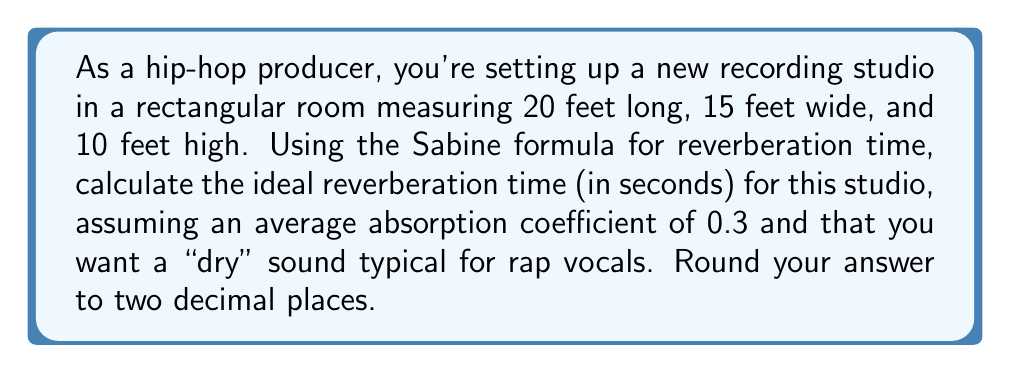What is the answer to this math problem? To solve this problem, we'll use the Sabine formula for reverberation time:

$$T = \frac{0.161V}{A}$$

Where:
$T$ = Reverberation time (seconds)
$V$ = Volume of the room (cubic feet)
$A$ = Total absorption (sabins)

Step 1: Calculate the volume of the room
$$V = 20 \text{ ft} \times 15 \text{ ft} \times 10 \text{ ft} = 3000 \text{ ft}^3$$

Step 2: Calculate the total surface area of the room
$$S = 2(20 \times 15 + 20 \times 10 + 15 \times 10) = 1300 \text{ ft}^2$$

Step 3: Calculate the total absorption
$$A = \alpha S = 0.3 \times 1300 = 390 \text{ sabins}$$
Where $\alpha$ is the average absorption coefficient.

Step 4: Apply the Sabine formula
$$T = \frac{0.161 \times 3000}{390} \approx 0.1238 \text{ seconds}$$

Step 5: Round to two decimal places
$$T \approx 0.12 \text{ seconds}$$

This short reverberation time is ideal for a "dry" sound typically used in rap vocals, allowing for clear and crisp recordings without excessive echo.
Answer: 0.12 seconds 